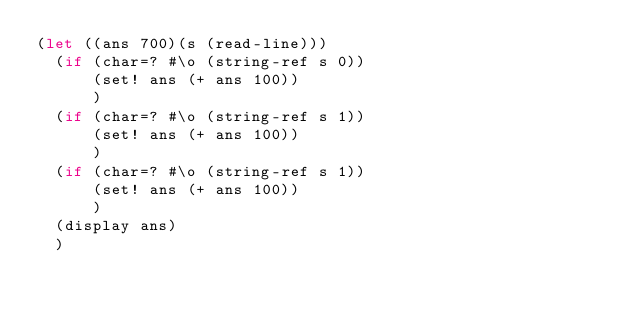Convert code to text. <code><loc_0><loc_0><loc_500><loc_500><_Scheme_>(let ((ans 700)(s (read-line)))
  (if (char=? #\o (string-ref s 0))
      (set! ans (+ ans 100))
      )
  (if (char=? #\o (string-ref s 1))
      (set! ans (+ ans 100))
      )
  (if (char=? #\o (string-ref s 1))
      (set! ans (+ ans 100))
      )
  (display ans)
  )
</code> 